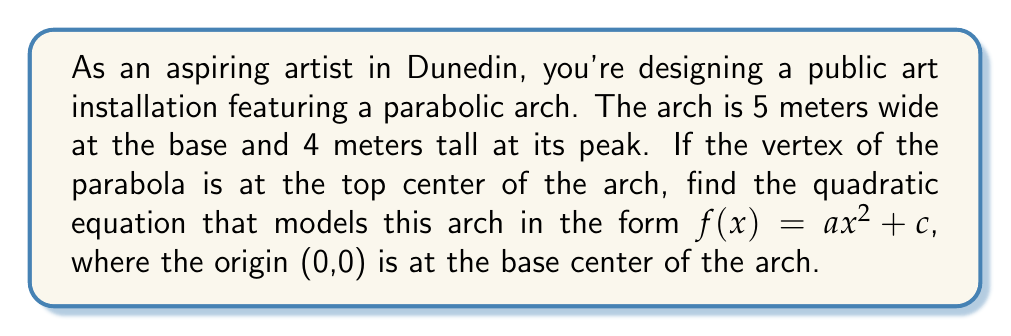Can you solve this math problem? Let's approach this step-by-step:

1) The general form of a quadratic equation with a vertical axis of symmetry is:
   $f(x) = a(x-h)^2 + k$
   where (h,k) is the vertex of the parabola.

2) We know the vertex is at the top center of the arch. Given the width is 5 meters and the height is 4 meters:
   h = 0 (center)
   k = 4 (height)

3) Our equation now looks like:
   $f(x) = a(x-0)^2 + 4$ or simply $f(x) = ax^2 + 4$

4) To find 'a', we can use the point where the arch meets the ground. The width is 5 meters, so this point is at (2.5, 0) or (-2.5, 0). Let's use (2.5, 0):

   $0 = a(2.5)^2 + 4$
   $-4 = a(6.25)$
   $a = -4/6.25 = -0.64$

5) Therefore, our final equation is:
   $f(x) = -0.64x^2 + 4$

This equation satisfies the form $f(x) = ax^2 + c$ as requested in the question.
Answer: $f(x) = -0.64x^2 + 4$ 